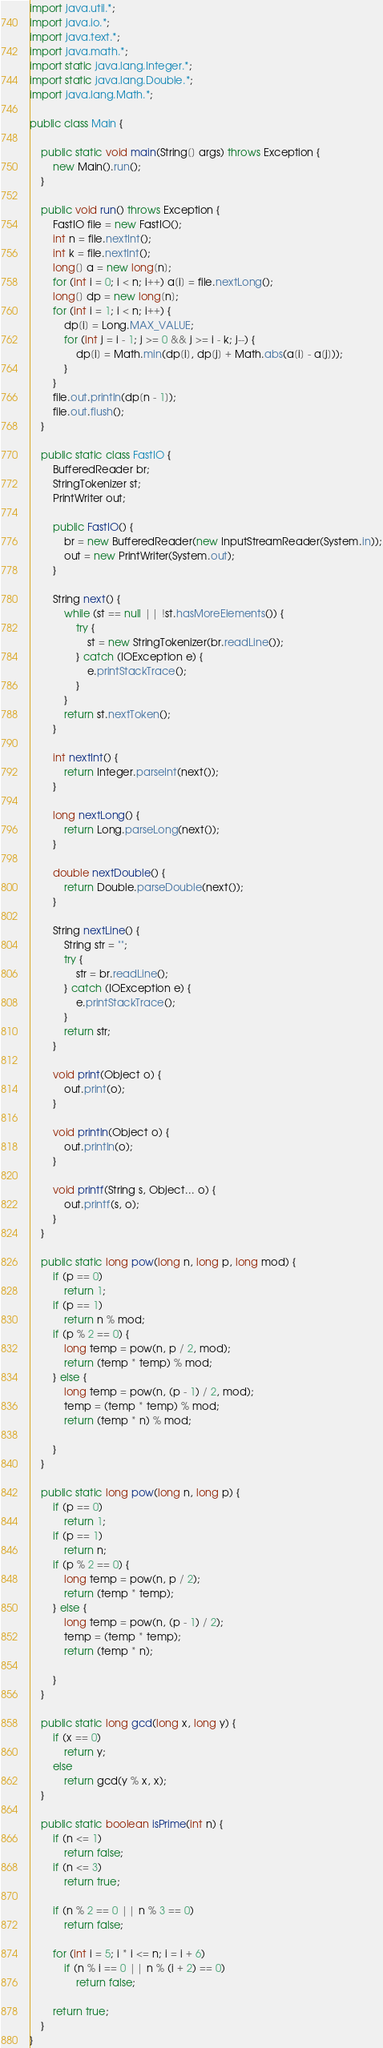<code> <loc_0><loc_0><loc_500><loc_500><_Java_>import java.util.*;
import java.io.*;
import java.text.*;
import java.math.*;
import static java.lang.Integer.*;
import static java.lang.Double.*;
import java.lang.Math.*;

public class Main {

	public static void main(String[] args) throws Exception {
		new Main().run();
	}

	public void run() throws Exception {
		FastIO file = new FastIO();
		int n = file.nextInt();
		int k = file.nextInt();
		long[] a = new long[n];
		for (int i = 0; i < n; i++) a[i] = file.nextLong();
		long[] dp = new long[n];
		for (int i = 1; i < n; i++) {
			dp[i] = Long.MAX_VALUE;
			for (int j = i - 1; j >= 0 && j >= i - k; j--) {
				dp[i] = Math.min(dp[i], dp[j] + Math.abs(a[i] - a[j]));
			}
		}
		file.out.println(dp[n - 1]);
		file.out.flush();
	}

	public static class FastIO {
		BufferedReader br;
		StringTokenizer st;
		PrintWriter out;

		public FastIO() {
			br = new BufferedReader(new InputStreamReader(System.in));
			out = new PrintWriter(System.out);
		}

		String next() {
			while (st == null || !st.hasMoreElements()) {
				try {
					st = new StringTokenizer(br.readLine());
				} catch (IOException e) {
					e.printStackTrace();
				}
			}
			return st.nextToken();
		}

		int nextInt() {
			return Integer.parseInt(next());
		}

		long nextLong() {
			return Long.parseLong(next());
		}

		double nextDouble() {
			return Double.parseDouble(next());
		}

		String nextLine() {
			String str = "";
			try {
				str = br.readLine();
			} catch (IOException e) {
				e.printStackTrace();
			}
			return str;
		}

		void print(Object o) {
			out.print(o);
		}

		void println(Object o) {
			out.println(o);
		}

		void printf(String s, Object... o) {
			out.printf(s, o);
		}
	}

	public static long pow(long n, long p, long mod) {
		if (p == 0)
			return 1;
		if (p == 1)
			return n % mod;
		if (p % 2 == 0) {
			long temp = pow(n, p / 2, mod);
			return (temp * temp) % mod;
		} else {
			long temp = pow(n, (p - 1) / 2, mod);
			temp = (temp * temp) % mod;
			return (temp * n) % mod;

		}
	}

	public static long pow(long n, long p) {
		if (p == 0)
			return 1;
		if (p == 1)
			return n;
		if (p % 2 == 0) {
			long temp = pow(n, p / 2);
			return (temp * temp);
		} else {
			long temp = pow(n, (p - 1) / 2);
			temp = (temp * temp);
			return (temp * n);

		}
	}

	public static long gcd(long x, long y) {
		if (x == 0)
			return y;
		else
			return gcd(y % x, x);
	}

	public static boolean isPrime(int n) {
		if (n <= 1)
			return false;
		if (n <= 3)
			return true;

		if (n % 2 == 0 || n % 3 == 0)
			return false;

		for (int i = 5; i * i <= n; i = i + 6)
			if (n % i == 0 || n % (i + 2) == 0)
				return false;

		return true;
	}
}
</code> 